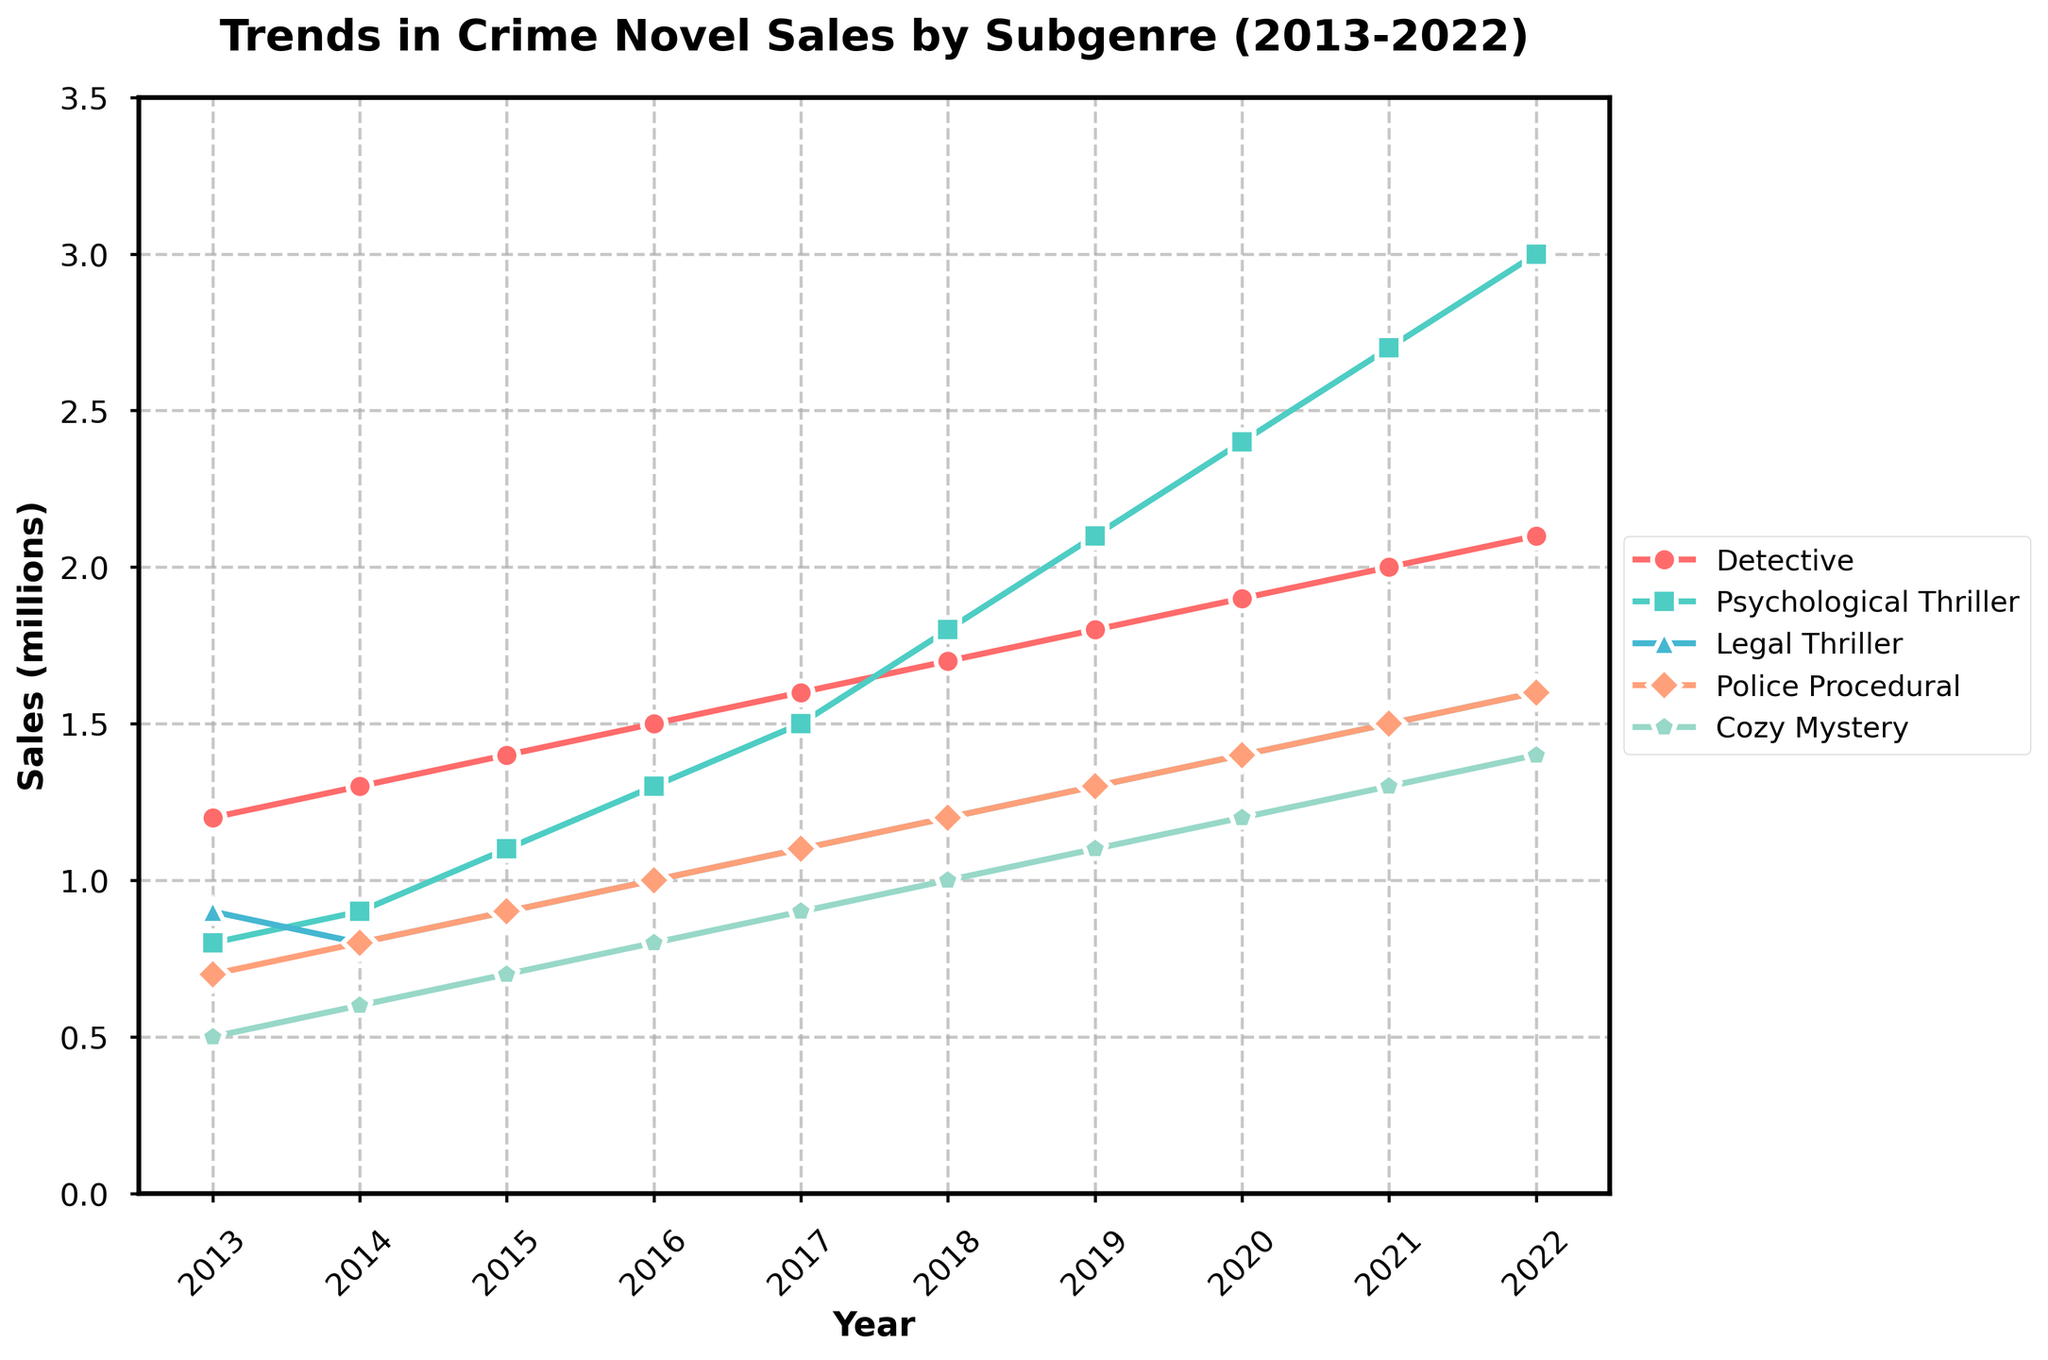What is the overall trend in sales for the Psychological Thriller subgenre from 2013 to 2022? The sales for Psychological Thriller show a rising trend throughout the years 2013 to 2022. Starting at 0.8 million in 2013, the sales increase yearly and reach 3.0 million in 2022.
Answer: Rising trend How much did Detective novel sales increase from 2013 to 2022? Detective novel sales were 1.2 million in 2013 and increased to 2.1 million in 2022. By subtracting the initial value from the final value, we get 2.1 - 1.2 = 0.9 million.
Answer: 0.9 million Which subgenre had the highest sales in 2022? The subgenre with the highest sales in 2022 is Psychological Thriller, with sales reaching 3.0 million.
Answer: Psychological Thriller In what year did Cozy Mystery sales first reach 1 million? Cozy Mystery sales reached 1 million for the first time in 2018.
Answer: 2018 How do Legal Thriller sales in 2022 compare to those in 2013? Legal Thriller sales were 0.9 million in 2013 and increased to 1.6 million in 2022. This shows a significant growth over the decade.
Answer: Increased Between which consecutive years did Police Procedural sales see the highest increase? By comparing yearly changes, the highest increase in Police Procedural sales occurred between 2013 (0.7) and 2014 (0.8).
Answer: 2013 to 2014 What is the average sales of the Detective subgenre across the entire period from 2013 to 2022? Adding the Detective sales from each year and dividing by the number of years: (1.2 + 1.3 + 1.4 + 1.5 + 1.6 + 1.7 + 1.8 + 1.9 + 2.0 + 2.1) / 10 = 1.65 million.
Answer: 1.65 million Which subgenre showed the most rapid growth between 2013 and 2022? By observing the slopes of the lines, Psychological Thriller shows the most rapid growth, starting from 0.8 million in 2013 and reaching 3.0 million in 2022.
Answer: Psychological Thriller In which year did Legal Thriller sales surpass 1.0 million for the first time? Legal Thriller sales surpassed 1.0 million for the first time in 2016, with sales of 1.0 million that year.
Answer: 2016 What is the combined sales of all subgenres in the year 2020? Summing the sales from each subgenre in 2020: Detective (1.9), Psychological Thriller (2.4), Legal Thriller (1.4), Police Procedural (1.4), Cozy Mystery (1.2) results in 1.9 + 2.4 + 1.4 + 1.4 + 1.2 = 8.3 million.
Answer: 8.3 million 